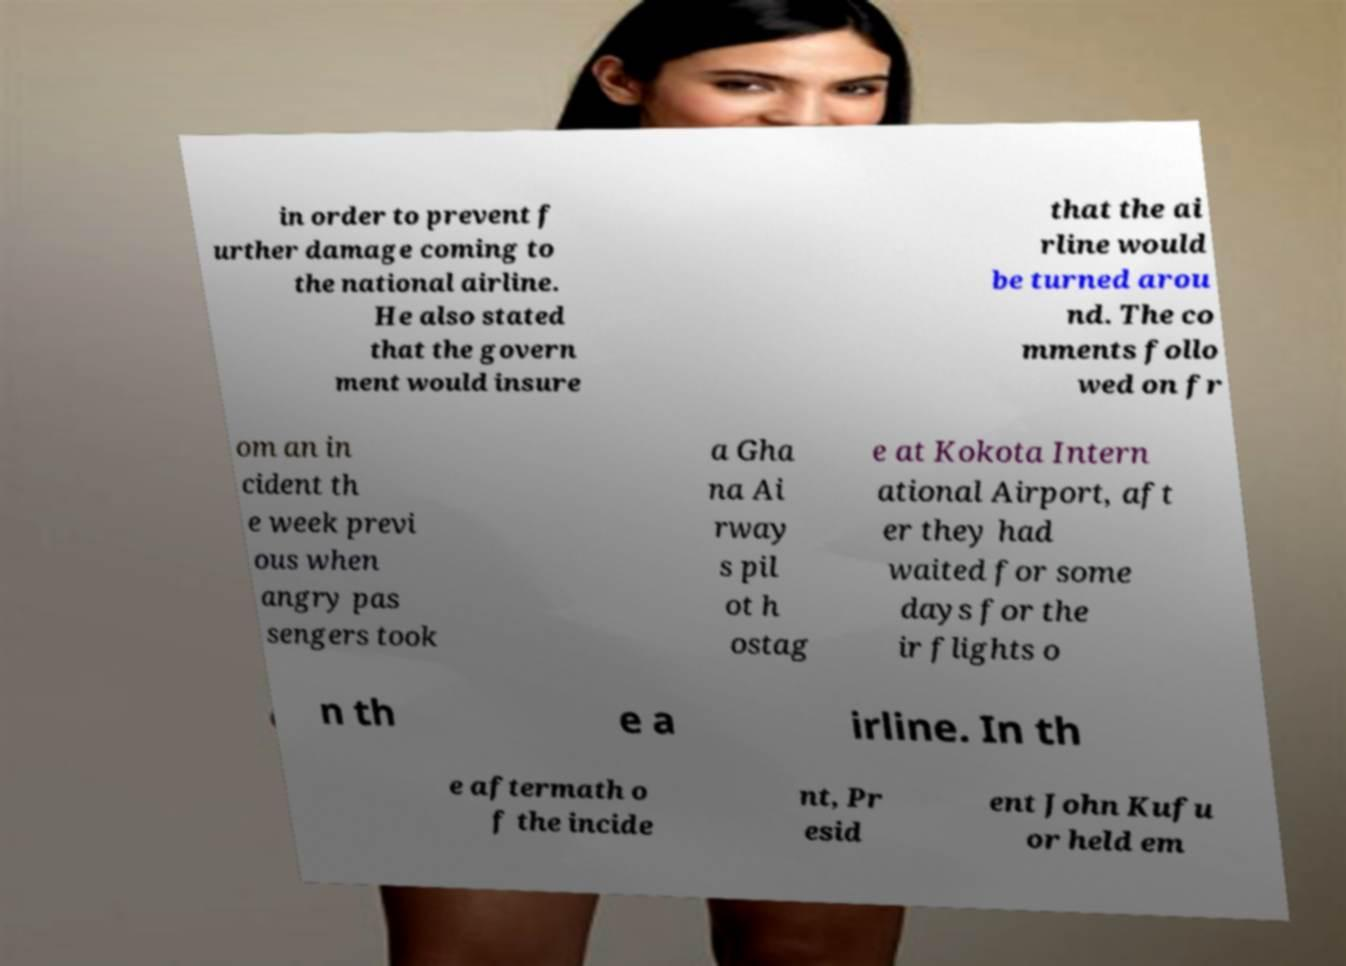I need the written content from this picture converted into text. Can you do that? in order to prevent f urther damage coming to the national airline. He also stated that the govern ment would insure that the ai rline would be turned arou nd. The co mments follo wed on fr om an in cident th e week previ ous when angry pas sengers took a Gha na Ai rway s pil ot h ostag e at Kokota Intern ational Airport, aft er they had waited for some days for the ir flights o n th e a irline. In th e aftermath o f the incide nt, Pr esid ent John Kufu or held em 